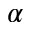Convert formula to latex. <formula><loc_0><loc_0><loc_500><loc_500>\alpha</formula> 